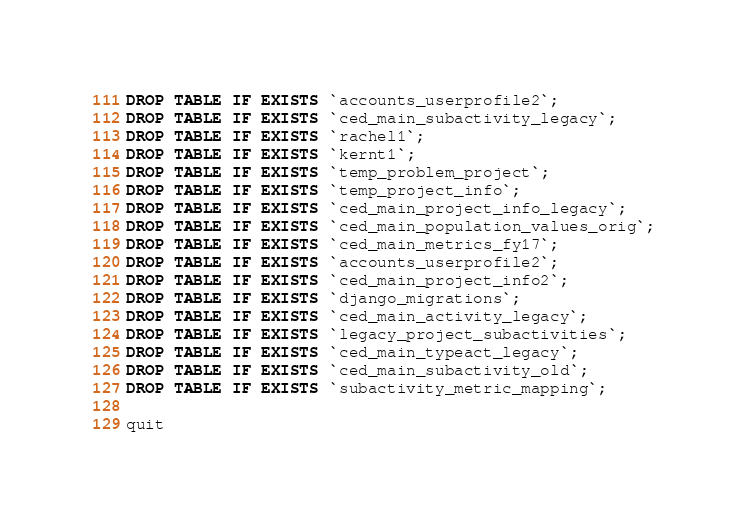<code> <loc_0><loc_0><loc_500><loc_500><_SQL_>DROP TABLE IF EXISTS `accounts_userprofile2`;
DROP TABLE IF EXISTS `ced_main_subactivity_legacy`;
DROP TABLE IF EXISTS `rachel1`;
DROP TABLE IF EXISTS `kernt1`;
DROP TABLE IF EXISTS `temp_problem_project`;
DROP TABLE IF EXISTS `temp_project_info`;
DROP TABLE IF EXISTS `ced_main_project_info_legacy`;
DROP TABLE IF EXISTS `ced_main_population_values_orig`;
DROP TABLE IF EXISTS `ced_main_metrics_fy17`;
DROP TABLE IF EXISTS `accounts_userprofile2`;
DROP TABLE IF EXISTS `ced_main_project_info2`;
DROP TABLE IF EXISTS `django_migrations`;
DROP TABLE IF EXISTS `ced_main_activity_legacy`;
DROP TABLE IF EXISTS `legacy_project_subactivities`;
DROP TABLE IF EXISTS `ced_main_typeact_legacy`;
DROP TABLE IF EXISTS `ced_main_subactivity_old`;
DROP TABLE IF EXISTS `subactivity_metric_mapping`;

quit</code> 